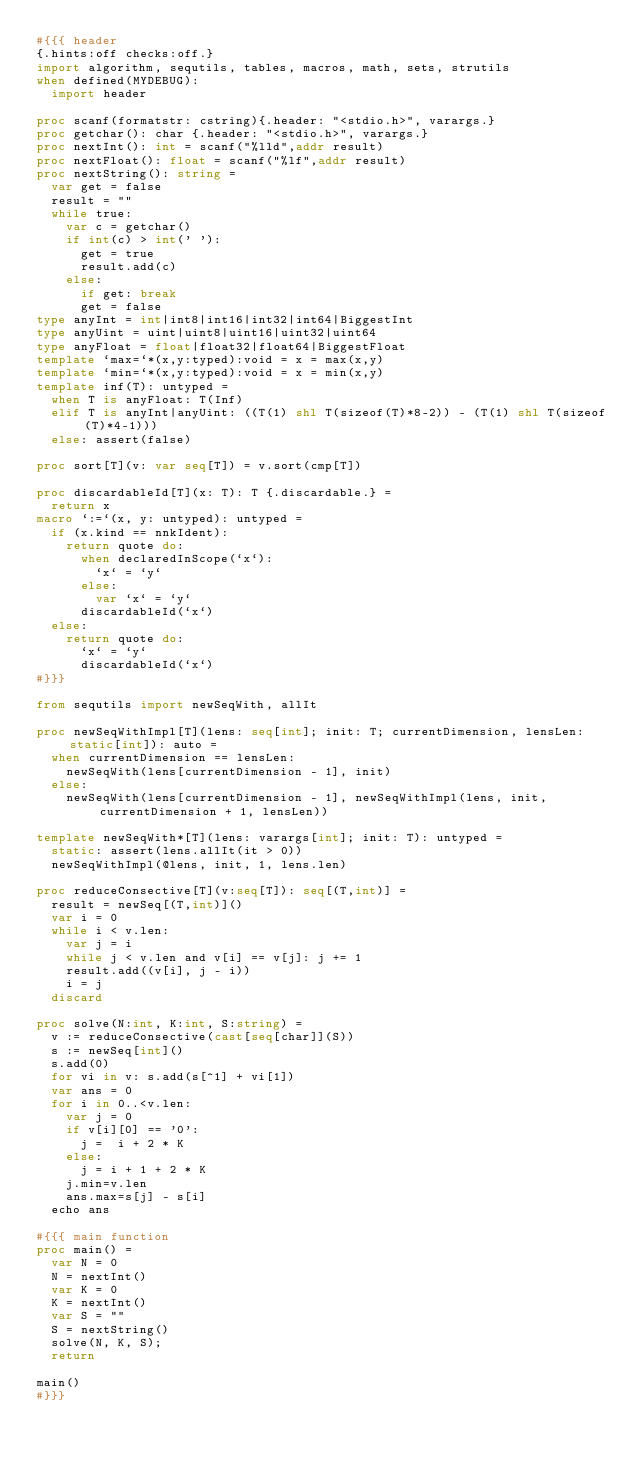<code> <loc_0><loc_0><loc_500><loc_500><_Nim_>#{{{ header
{.hints:off checks:off.}
import algorithm, sequtils, tables, macros, math, sets, strutils
when defined(MYDEBUG):
  import header

proc scanf(formatstr: cstring){.header: "<stdio.h>", varargs.}
proc getchar(): char {.header: "<stdio.h>", varargs.}
proc nextInt(): int = scanf("%lld",addr result)
proc nextFloat(): float = scanf("%lf",addr result)
proc nextString(): string =
  var get = false
  result = ""
  while true:
    var c = getchar()
    if int(c) > int(' '):
      get = true
      result.add(c)
    else:
      if get: break
      get = false
type anyInt = int|int8|int16|int32|int64|BiggestInt
type anyUint = uint|uint8|uint16|uint32|uint64
type anyFloat = float|float32|float64|BiggestFloat
template `max=`*(x,y:typed):void = x = max(x,y)
template `min=`*(x,y:typed):void = x = min(x,y)
template inf(T): untyped = 
  when T is anyFloat: T(Inf)
  elif T is anyInt|anyUint: ((T(1) shl T(sizeof(T)*8-2)) - (T(1) shl T(sizeof(T)*4-1)))
  else: assert(false)

proc sort[T](v: var seq[T]) = v.sort(cmp[T])

proc discardableId[T](x: T): T {.discardable.} =
  return x
macro `:=`(x, y: untyped): untyped =
  if (x.kind == nnkIdent):
    return quote do:
      when declaredInScope(`x`):
        `x` = `y`
      else:
        var `x` = `y`
      discardableId(`x`)
  else:
    return quote do:
      `x` = `y`
      discardableId(`x`)
#}}}

from sequtils import newSeqWith, allIt

proc newSeqWithImpl[T](lens: seq[int]; init: T; currentDimension, lensLen: static[int]): auto =
  when currentDimension == lensLen:
    newSeqWith(lens[currentDimension - 1], init)
  else:
    newSeqWith(lens[currentDimension - 1], newSeqWithImpl(lens, init, currentDimension + 1, lensLen))

template newSeqWith*[T](lens: varargs[int]; init: T): untyped =
  static: assert(lens.allIt(it > 0))
  newSeqWithImpl(@lens, init, 1, lens.len)

proc reduceConsective[T](v:seq[T]): seq[(T,int)] =
  result = newSeq[(T,int)]()
  var i = 0
  while i < v.len:
    var j = i
    while j < v.len and v[i] == v[j]: j += 1
    result.add((v[i], j - i))
    i = j
  discard

proc solve(N:int, K:int, S:string) =
  v := reduceConsective(cast[seq[char]](S))
  s := newSeq[int]()
  s.add(0)
  for vi in v: s.add(s[^1] + vi[1])
  var ans = 0
  for i in 0..<v.len:
    var j = 0
    if v[i][0] == '0':
      j =  i + 2 * K
    else:
      j = i + 1 + 2 * K
    j.min=v.len
    ans.max=s[j] - s[i]
  echo ans

#{{{ main function
proc main() =
  var N = 0
  N = nextInt()
  var K = 0
  K = nextInt()
  var S = ""
  S = nextString()
  solve(N, K, S);
  return

main()
#}}}
</code> 